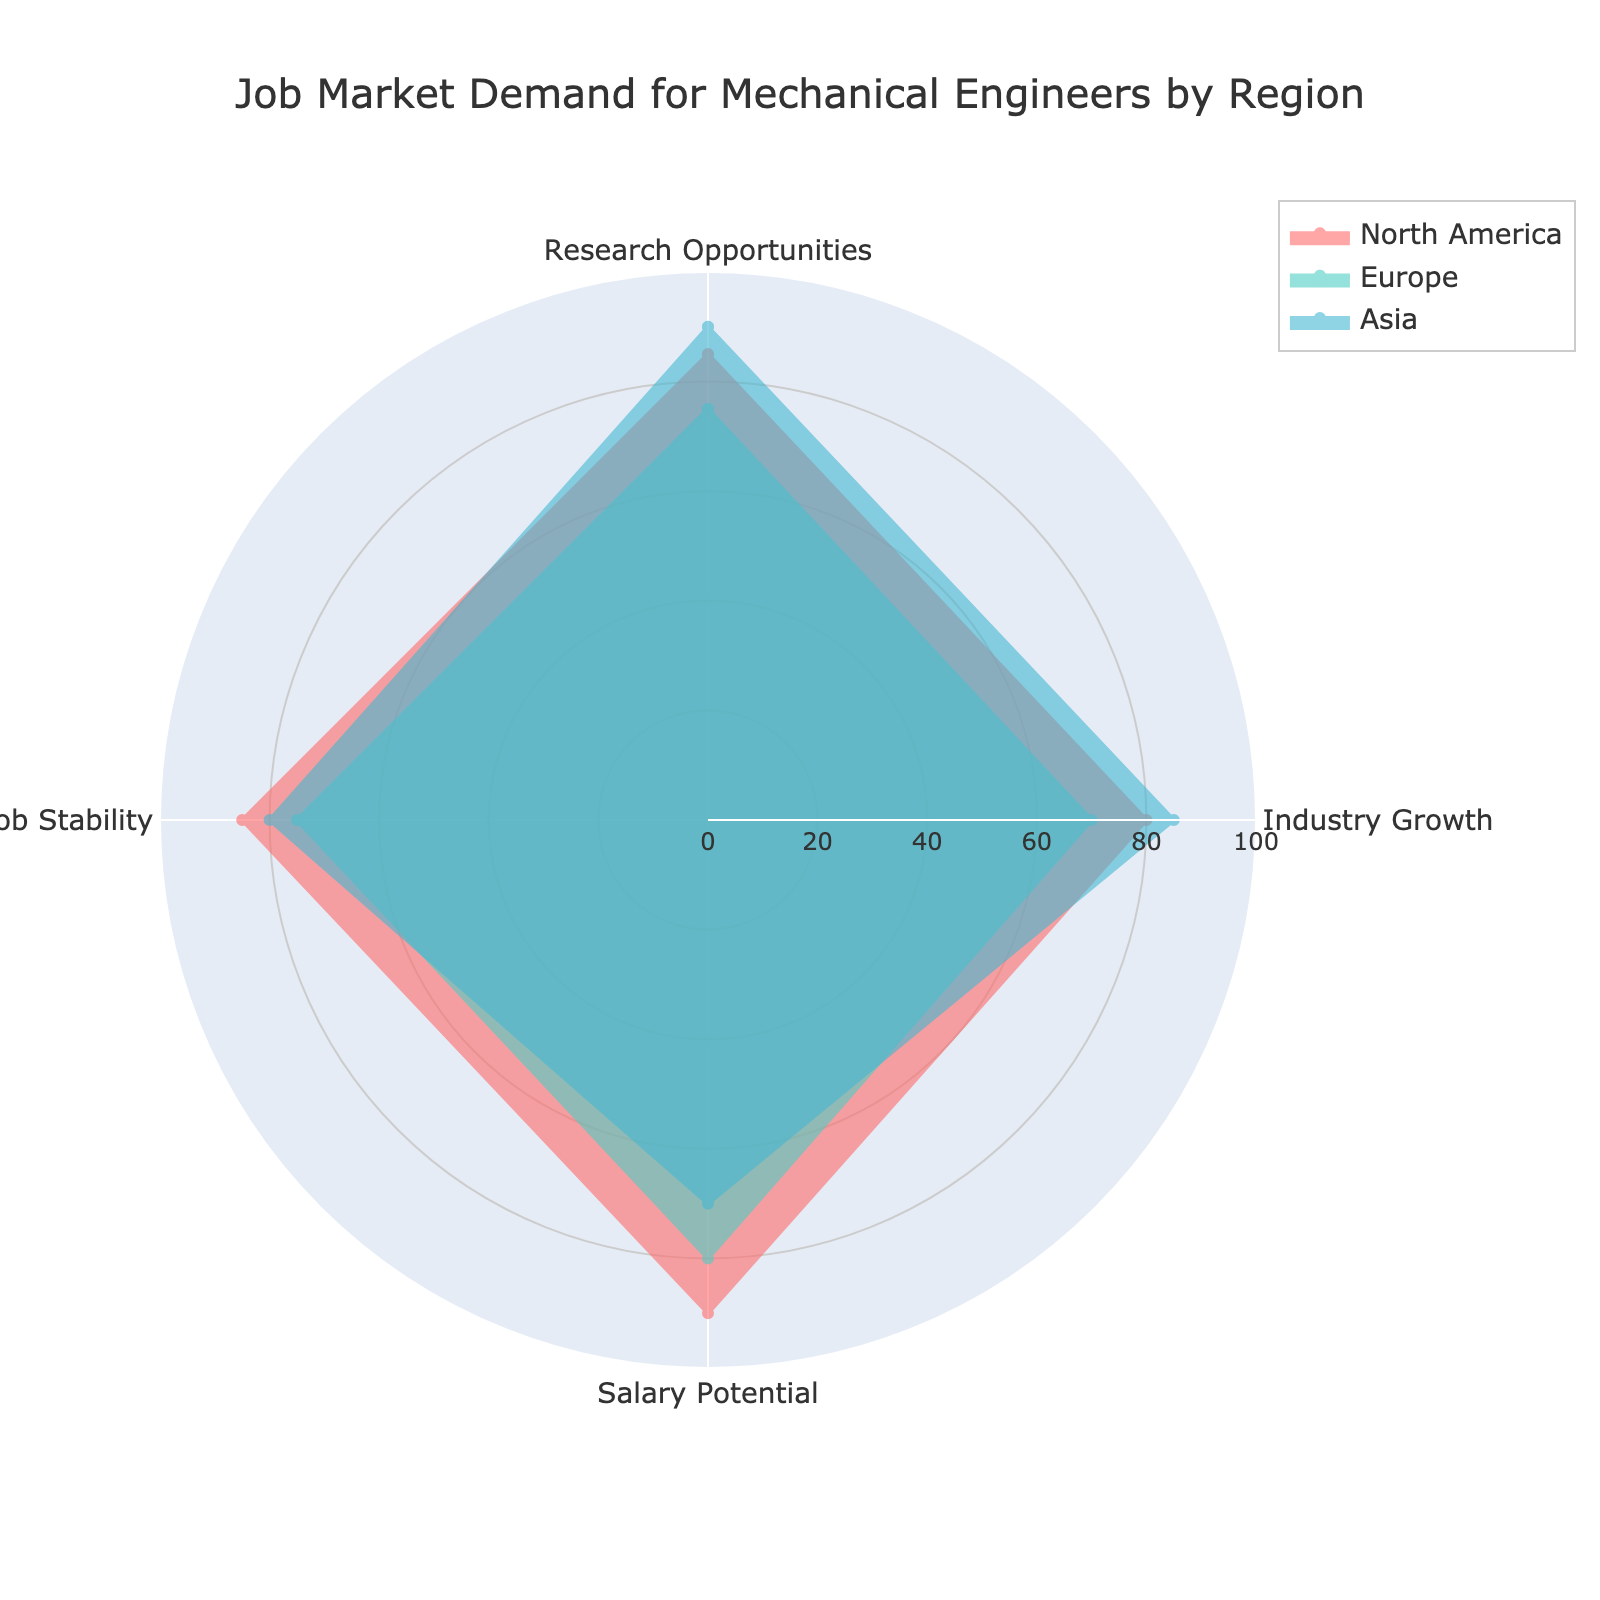what are the four categories of job market demand shown in the radar chart? The radar chart shows four distinct categories of job market demand, each represented by a line: Research Opportunities, Industry Growth, Salary Potential, and Job Stability.
Answer: Research Opportunities, Industry Growth, Salary Potential, and Job Stability Which region has the highest research opportunities? By examining the radial lines representing Research Opportunities, we see that Asia reaches the highest point among the three regions.
Answer: Asia How does job stability in North America compare to Europe? To compare job stability, look at the radial line for Job Stability in both North America and Europe. North America's line for Job Stability is at 85, while Europe's is at 75, indicating that North America has higher job stability.
Answer: North America has higher job stability than Europe What's the average salary potential across all regions? The salary potential for North America, Europe, and Asia are 90, 80, and 70, respectively. Adding these (90 + 80 + 70) gives us 240. Dividing by 3 regions yields an average value of 80.
Answer: 80 In which category does Europe fall behind both North America and Asia? By reviewing each category, we can see that Europe falls behind both North America and Asia in Industry Growth where its value is the lowest at 70, compared to North America's 80 and Asia's 85.
Answer: Industry Growth Which region shows the highest overall demand if you average the values across all categories? To determine the highest overall demand, calculate the average for each region across all four categories. North America's values are (85+80+90+85), summing to 340, averaging to 85. Europe's are (75+70+80+75), summing to 300, averaging to 75. Asia's are (90+85+70+80), summing to 325, averaging to 81.25. North America has the highest overall average.
Answer: North America Do any regions have equivalent scores in any categories? Checking each category value: All values are different except for Job Stability in two regions. North America and Asia both have a score of 85 in Job Stability.
Answer: North America and Asia have equivalent scores in Job Stability What is the difference in research opportunities between Asia and Europe? Looking at the Research Opportunities values for Asia (90) and Europe (75), subtract the values to find the difference: 90 - 75 = 15.
Answer: 15 